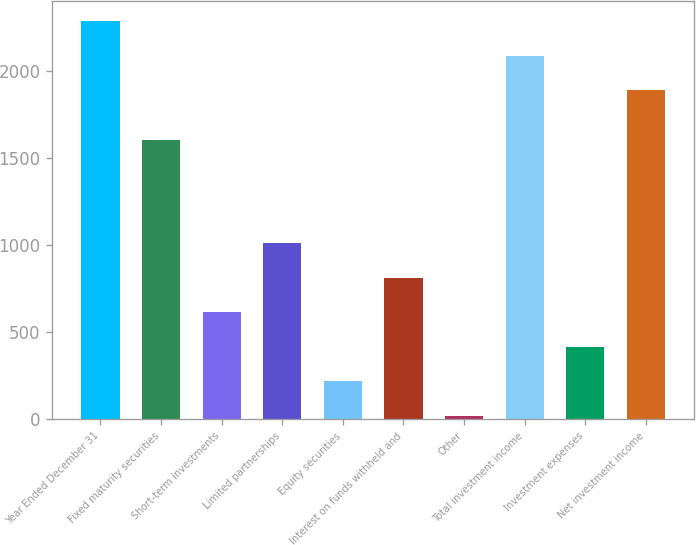<chart> <loc_0><loc_0><loc_500><loc_500><bar_chart><fcel>Year Ended December 31<fcel>Fixed maturity securities<fcel>Short-term investments<fcel>Limited partnerships<fcel>Equity securities<fcel>Interest on funds withheld and<fcel>Other<fcel>Total investment income<fcel>Investment expenses<fcel>Net investment income<nl><fcel>2288.96<fcel>1607.5<fcel>615.29<fcel>1012.35<fcel>218.23<fcel>813.82<fcel>19.7<fcel>2090.43<fcel>416.76<fcel>1891.9<nl></chart> 